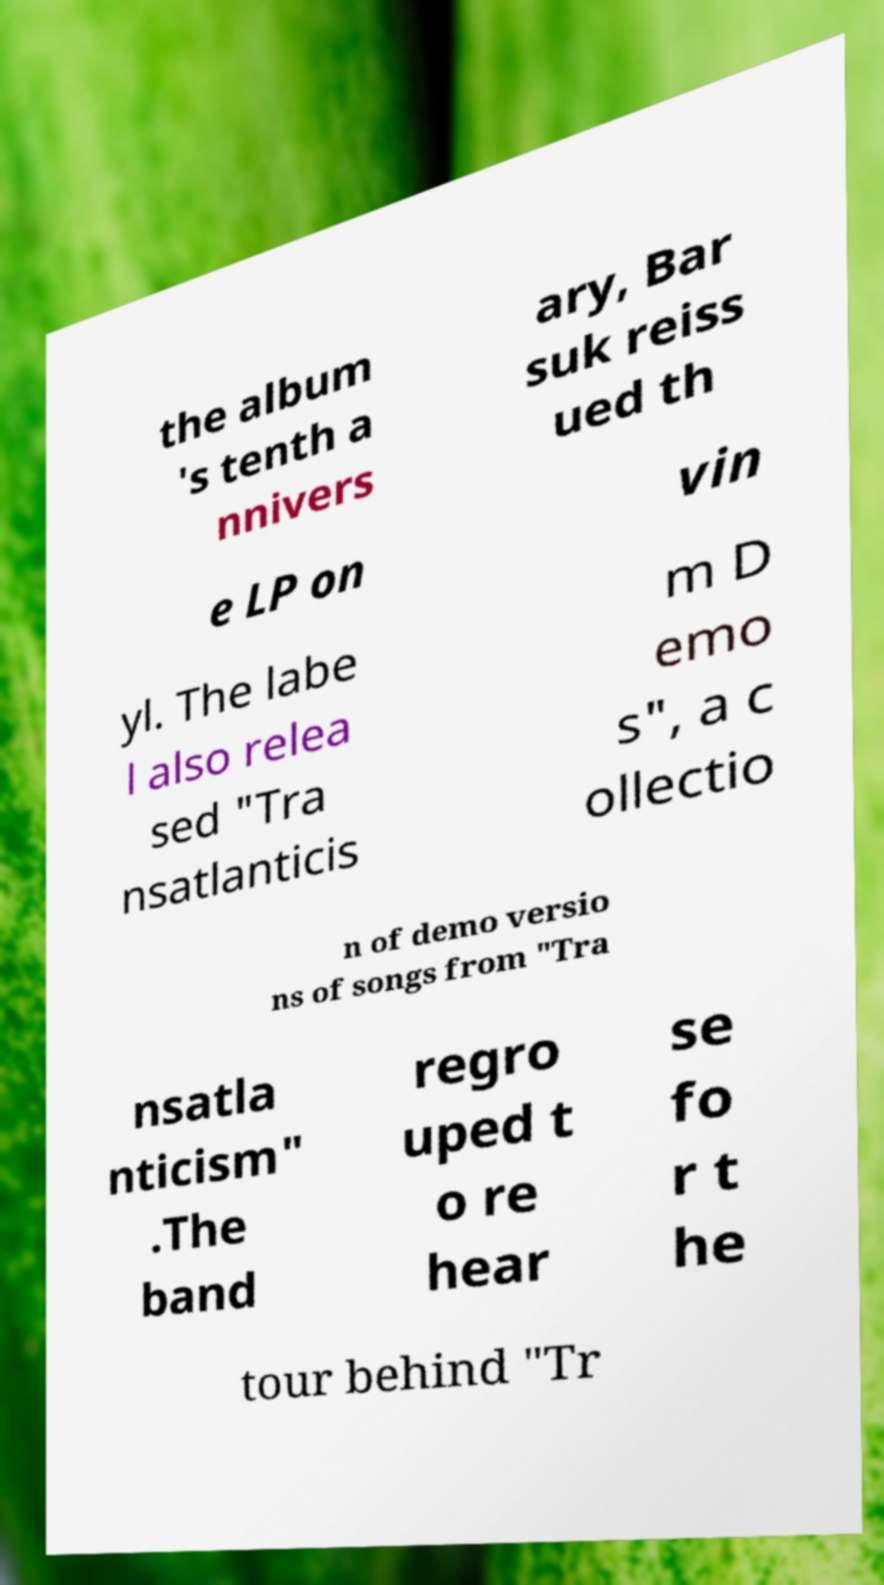There's text embedded in this image that I need extracted. Can you transcribe it verbatim? the album 's tenth a nnivers ary, Bar suk reiss ued th e LP on vin yl. The labe l also relea sed "Tra nsatlanticis m D emo s", a c ollectio n of demo versio ns of songs from "Tra nsatla nticism" .The band regro uped t o re hear se fo r t he tour behind "Tr 